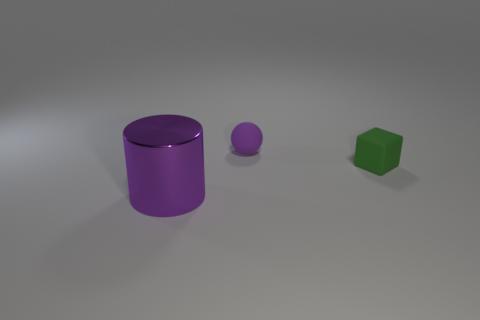What shapes are present in this image? The image contains three different shapes. There is a cylinder and two spheres in varying shades of purple, and a green block in the shape of a cube. 